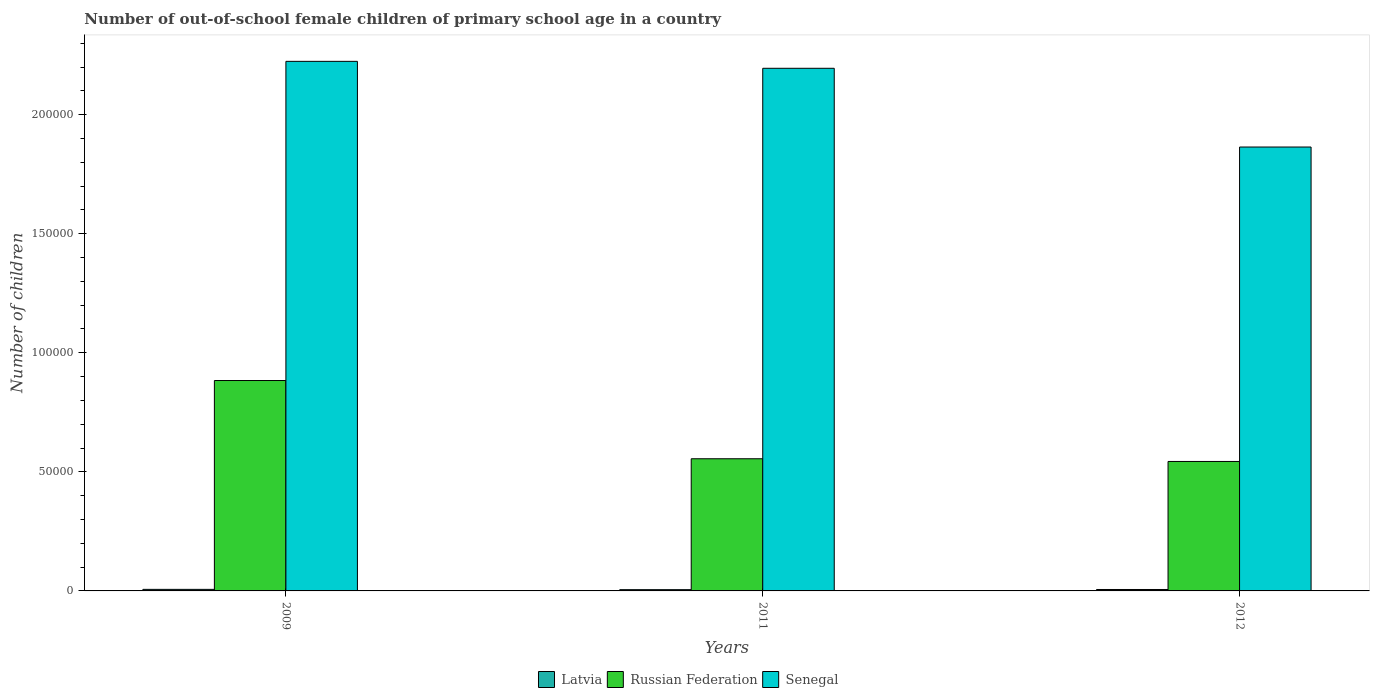How many groups of bars are there?
Make the answer very short. 3. Are the number of bars per tick equal to the number of legend labels?
Provide a succinct answer. Yes. Are the number of bars on each tick of the X-axis equal?
Your answer should be compact. Yes. How many bars are there on the 1st tick from the right?
Give a very brief answer. 3. What is the number of out-of-school female children in Latvia in 2011?
Make the answer very short. 527. Across all years, what is the maximum number of out-of-school female children in Russian Federation?
Provide a succinct answer. 8.84e+04. Across all years, what is the minimum number of out-of-school female children in Senegal?
Give a very brief answer. 1.86e+05. In which year was the number of out-of-school female children in Latvia minimum?
Your answer should be compact. 2011. What is the total number of out-of-school female children in Russian Federation in the graph?
Make the answer very short. 1.98e+05. What is the difference between the number of out-of-school female children in Senegal in 2011 and the number of out-of-school female children in Latvia in 2009?
Your answer should be very brief. 2.19e+05. What is the average number of out-of-school female children in Latvia per year?
Make the answer very short. 593.33. In the year 2009, what is the difference between the number of out-of-school female children in Russian Federation and number of out-of-school female children in Latvia?
Your response must be concise. 8.77e+04. In how many years, is the number of out-of-school female children in Latvia greater than 70000?
Offer a terse response. 0. What is the ratio of the number of out-of-school female children in Senegal in 2009 to that in 2012?
Keep it short and to the point. 1.19. Is the number of out-of-school female children in Senegal in 2009 less than that in 2011?
Your response must be concise. No. What is the difference between the highest and the second highest number of out-of-school female children in Senegal?
Provide a succinct answer. 2914. What is the difference between the highest and the lowest number of out-of-school female children in Latvia?
Make the answer very short. 126. What does the 3rd bar from the left in 2012 represents?
Make the answer very short. Senegal. What does the 1st bar from the right in 2009 represents?
Your answer should be very brief. Senegal. Is it the case that in every year, the sum of the number of out-of-school female children in Senegal and number of out-of-school female children in Russian Federation is greater than the number of out-of-school female children in Latvia?
Keep it short and to the point. Yes. How many bars are there?
Ensure brevity in your answer.  9. How many years are there in the graph?
Make the answer very short. 3. Are the values on the major ticks of Y-axis written in scientific E-notation?
Ensure brevity in your answer.  No. How many legend labels are there?
Your response must be concise. 3. How are the legend labels stacked?
Make the answer very short. Horizontal. What is the title of the graph?
Provide a short and direct response. Number of out-of-school female children of primary school age in a country. Does "Sudan" appear as one of the legend labels in the graph?
Provide a succinct answer. No. What is the label or title of the Y-axis?
Offer a terse response. Number of children. What is the Number of children of Latvia in 2009?
Provide a short and direct response. 653. What is the Number of children of Russian Federation in 2009?
Offer a very short reply. 8.84e+04. What is the Number of children in Senegal in 2009?
Keep it short and to the point. 2.22e+05. What is the Number of children of Latvia in 2011?
Keep it short and to the point. 527. What is the Number of children in Russian Federation in 2011?
Offer a terse response. 5.55e+04. What is the Number of children in Senegal in 2011?
Give a very brief answer. 2.19e+05. What is the Number of children in Latvia in 2012?
Ensure brevity in your answer.  600. What is the Number of children of Russian Federation in 2012?
Your answer should be compact. 5.44e+04. What is the Number of children of Senegal in 2012?
Give a very brief answer. 1.86e+05. Across all years, what is the maximum Number of children of Latvia?
Offer a very short reply. 653. Across all years, what is the maximum Number of children in Russian Federation?
Provide a succinct answer. 8.84e+04. Across all years, what is the maximum Number of children of Senegal?
Offer a very short reply. 2.22e+05. Across all years, what is the minimum Number of children of Latvia?
Your answer should be very brief. 527. Across all years, what is the minimum Number of children of Russian Federation?
Offer a very short reply. 5.44e+04. Across all years, what is the minimum Number of children in Senegal?
Provide a succinct answer. 1.86e+05. What is the total Number of children in Latvia in the graph?
Offer a terse response. 1780. What is the total Number of children of Russian Federation in the graph?
Provide a succinct answer. 1.98e+05. What is the total Number of children of Senegal in the graph?
Your answer should be very brief. 6.28e+05. What is the difference between the Number of children of Latvia in 2009 and that in 2011?
Provide a short and direct response. 126. What is the difference between the Number of children of Russian Federation in 2009 and that in 2011?
Ensure brevity in your answer.  3.29e+04. What is the difference between the Number of children in Senegal in 2009 and that in 2011?
Give a very brief answer. 2914. What is the difference between the Number of children of Latvia in 2009 and that in 2012?
Provide a succinct answer. 53. What is the difference between the Number of children of Russian Federation in 2009 and that in 2012?
Make the answer very short. 3.40e+04. What is the difference between the Number of children of Senegal in 2009 and that in 2012?
Provide a short and direct response. 3.60e+04. What is the difference between the Number of children in Latvia in 2011 and that in 2012?
Give a very brief answer. -73. What is the difference between the Number of children in Russian Federation in 2011 and that in 2012?
Your response must be concise. 1138. What is the difference between the Number of children in Senegal in 2011 and that in 2012?
Offer a very short reply. 3.31e+04. What is the difference between the Number of children of Latvia in 2009 and the Number of children of Russian Federation in 2011?
Ensure brevity in your answer.  -5.48e+04. What is the difference between the Number of children in Latvia in 2009 and the Number of children in Senegal in 2011?
Ensure brevity in your answer.  -2.19e+05. What is the difference between the Number of children in Russian Federation in 2009 and the Number of children in Senegal in 2011?
Your answer should be compact. -1.31e+05. What is the difference between the Number of children of Latvia in 2009 and the Number of children of Russian Federation in 2012?
Make the answer very short. -5.37e+04. What is the difference between the Number of children of Latvia in 2009 and the Number of children of Senegal in 2012?
Provide a succinct answer. -1.86e+05. What is the difference between the Number of children of Russian Federation in 2009 and the Number of children of Senegal in 2012?
Your response must be concise. -9.80e+04. What is the difference between the Number of children in Latvia in 2011 and the Number of children in Russian Federation in 2012?
Keep it short and to the point. -5.38e+04. What is the difference between the Number of children in Latvia in 2011 and the Number of children in Senegal in 2012?
Provide a succinct answer. -1.86e+05. What is the difference between the Number of children of Russian Federation in 2011 and the Number of children of Senegal in 2012?
Keep it short and to the point. -1.31e+05. What is the average Number of children in Latvia per year?
Make the answer very short. 593.33. What is the average Number of children of Russian Federation per year?
Offer a very short reply. 6.61e+04. What is the average Number of children of Senegal per year?
Your answer should be very brief. 2.09e+05. In the year 2009, what is the difference between the Number of children in Latvia and Number of children in Russian Federation?
Ensure brevity in your answer.  -8.77e+04. In the year 2009, what is the difference between the Number of children of Latvia and Number of children of Senegal?
Make the answer very short. -2.22e+05. In the year 2009, what is the difference between the Number of children in Russian Federation and Number of children in Senegal?
Ensure brevity in your answer.  -1.34e+05. In the year 2011, what is the difference between the Number of children in Latvia and Number of children in Russian Federation?
Offer a terse response. -5.50e+04. In the year 2011, what is the difference between the Number of children in Latvia and Number of children in Senegal?
Your answer should be compact. -2.19e+05. In the year 2011, what is the difference between the Number of children in Russian Federation and Number of children in Senegal?
Provide a short and direct response. -1.64e+05. In the year 2012, what is the difference between the Number of children of Latvia and Number of children of Russian Federation?
Your answer should be compact. -5.38e+04. In the year 2012, what is the difference between the Number of children in Latvia and Number of children in Senegal?
Ensure brevity in your answer.  -1.86e+05. In the year 2012, what is the difference between the Number of children of Russian Federation and Number of children of Senegal?
Provide a succinct answer. -1.32e+05. What is the ratio of the Number of children of Latvia in 2009 to that in 2011?
Your answer should be compact. 1.24. What is the ratio of the Number of children in Russian Federation in 2009 to that in 2011?
Offer a terse response. 1.59. What is the ratio of the Number of children in Senegal in 2009 to that in 2011?
Offer a very short reply. 1.01. What is the ratio of the Number of children of Latvia in 2009 to that in 2012?
Your response must be concise. 1.09. What is the ratio of the Number of children of Russian Federation in 2009 to that in 2012?
Offer a very short reply. 1.63. What is the ratio of the Number of children of Senegal in 2009 to that in 2012?
Your response must be concise. 1.19. What is the ratio of the Number of children in Latvia in 2011 to that in 2012?
Offer a terse response. 0.88. What is the ratio of the Number of children of Russian Federation in 2011 to that in 2012?
Provide a short and direct response. 1.02. What is the ratio of the Number of children of Senegal in 2011 to that in 2012?
Offer a terse response. 1.18. What is the difference between the highest and the second highest Number of children of Russian Federation?
Offer a very short reply. 3.29e+04. What is the difference between the highest and the second highest Number of children in Senegal?
Keep it short and to the point. 2914. What is the difference between the highest and the lowest Number of children of Latvia?
Give a very brief answer. 126. What is the difference between the highest and the lowest Number of children of Russian Federation?
Offer a terse response. 3.40e+04. What is the difference between the highest and the lowest Number of children of Senegal?
Offer a very short reply. 3.60e+04. 